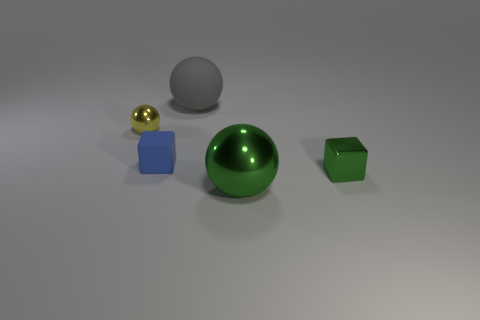How many other things are there of the same material as the green ball?
Offer a terse response. 2. Are there more small purple rubber spheres than green metallic balls?
Give a very brief answer. No. There is a small block right of the small block that is on the left side of the large thing in front of the small green block; what is its material?
Your answer should be compact. Metal. Does the large shiny object have the same color as the tiny metallic block?
Give a very brief answer. Yes. Are there any rubber balls of the same color as the small metallic ball?
Your response must be concise. No. There is a metallic thing that is the same size as the matte sphere; what is its shape?
Offer a terse response. Sphere. Are there fewer large blue metal objects than tiny blue matte blocks?
Offer a very short reply. Yes. What number of other blue rubber things have the same size as the blue matte object?
Offer a very short reply. 0. The large thing that is the same color as the small metal block is what shape?
Make the answer very short. Sphere. What is the material of the blue thing?
Provide a short and direct response. Rubber. 